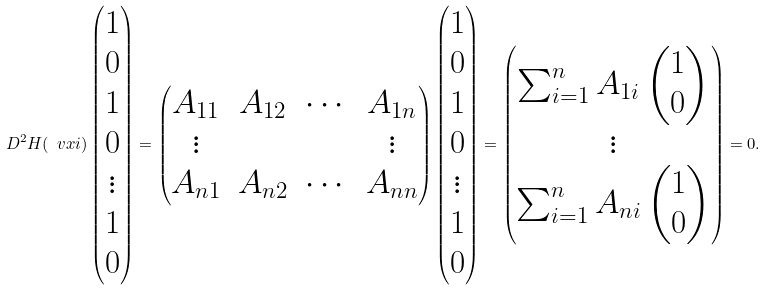<formula> <loc_0><loc_0><loc_500><loc_500>D ^ { 2 } H ( \ v x i ) \begin{pmatrix} 1 \\ 0 \\ 1 \\ 0 \\ \vdots \\ 1 \\ 0 \end{pmatrix} = \begin{pmatrix} A _ { 1 1 } & A _ { 1 2 } & \cdots & A _ { 1 n } \\ \vdots & & & \vdots \\ A _ { n 1 } & A _ { n 2 } & \cdots & A _ { n n } \end{pmatrix} \begin{pmatrix} 1 \\ 0 \\ 1 \\ 0 \\ \vdots \\ 1 \\ 0 \end{pmatrix} = \begin{pmatrix} \sum _ { i = 1 } ^ { n } A _ { 1 i } \begin{pmatrix} 1 \\ 0 \end{pmatrix} \\ \vdots \\ \sum _ { i = 1 } ^ { n } A _ { n i } \begin{pmatrix} 1 \\ 0 \end{pmatrix} \end{pmatrix} = 0 .</formula> 